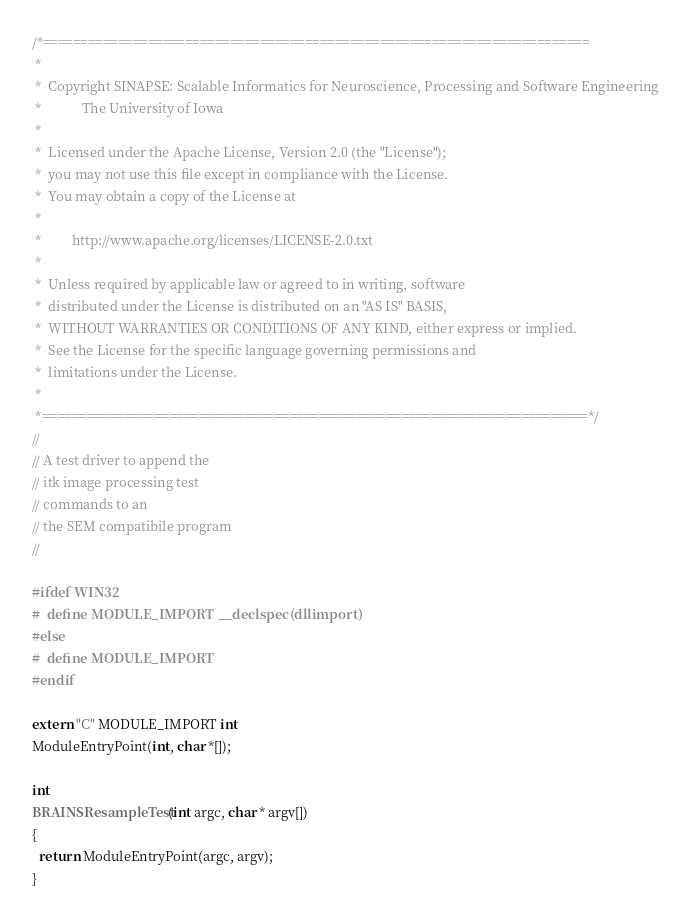<code> <loc_0><loc_0><loc_500><loc_500><_C++_>/*=========================================================================
 *
 *  Copyright SINAPSE: Scalable Informatics for Neuroscience, Processing and Software Engineering
 *            The University of Iowa
 *
 *  Licensed under the Apache License, Version 2.0 (the "License");
 *  you may not use this file except in compliance with the License.
 *  You may obtain a copy of the License at
 *
 *         http://www.apache.org/licenses/LICENSE-2.0.txt
 *
 *  Unless required by applicable law or agreed to in writing, software
 *  distributed under the License is distributed on an "AS IS" BASIS,
 *  WITHOUT WARRANTIES OR CONDITIONS OF ANY KIND, either express or implied.
 *  See the License for the specific language governing permissions and
 *  limitations under the License.
 *
 *=========================================================================*/
//
// A test driver to append the
// itk image processing test
// commands to an
// the SEM compatibile program
//

#ifdef WIN32
#  define MODULE_IMPORT __declspec(dllimport)
#else
#  define MODULE_IMPORT
#endif

extern "C" MODULE_IMPORT int
ModuleEntryPoint(int, char *[]);

int
BRAINSResampleTest(int argc, char * argv[])
{
  return ModuleEntryPoint(argc, argv);
}
</code> 